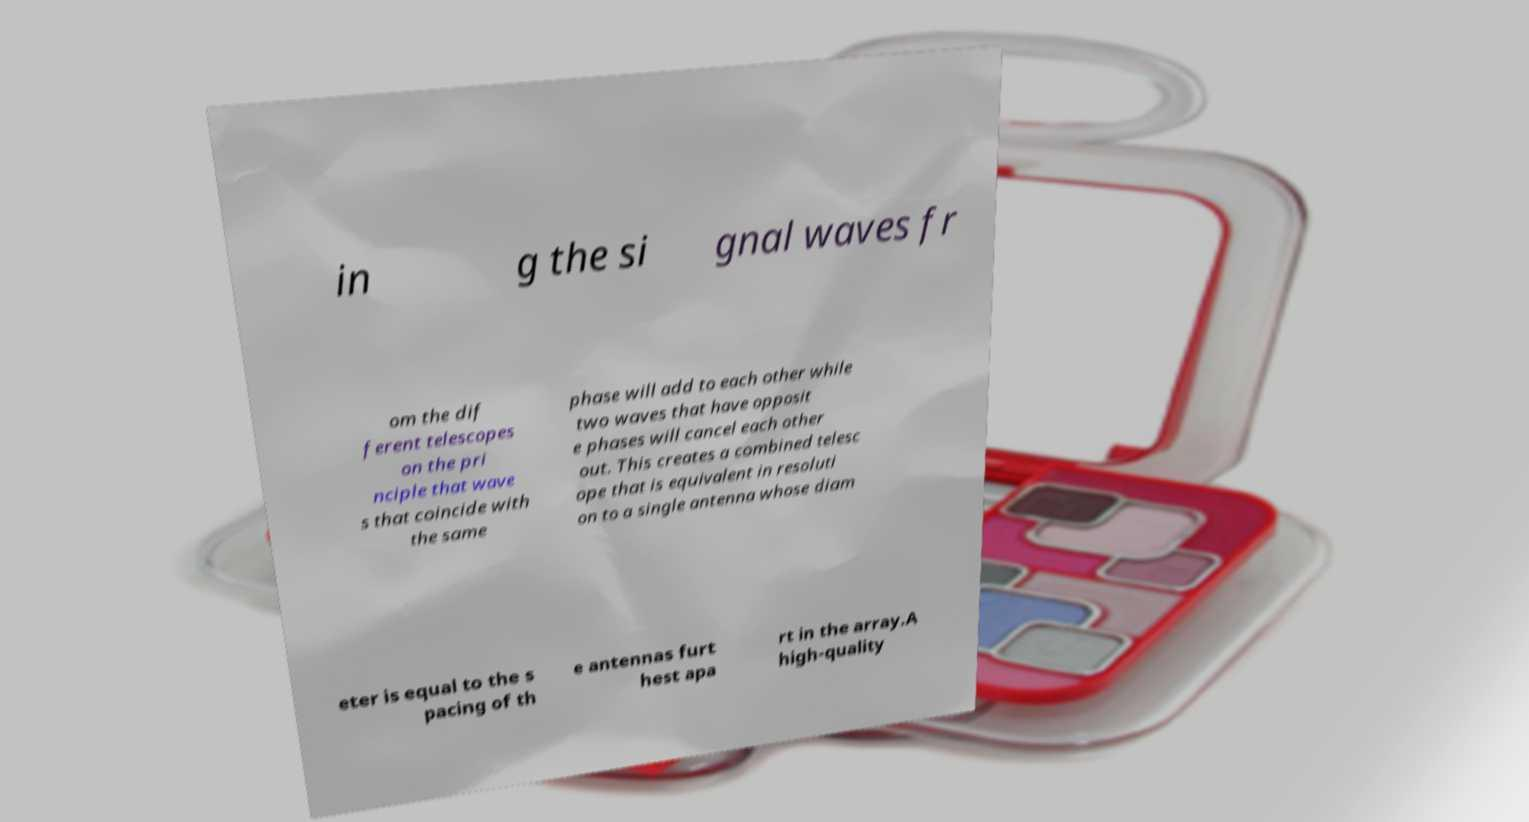Could you assist in decoding the text presented in this image and type it out clearly? in g the si gnal waves fr om the dif ferent telescopes on the pri nciple that wave s that coincide with the same phase will add to each other while two waves that have opposit e phases will cancel each other out. This creates a combined telesc ope that is equivalent in resoluti on to a single antenna whose diam eter is equal to the s pacing of th e antennas furt hest apa rt in the array.A high-quality 